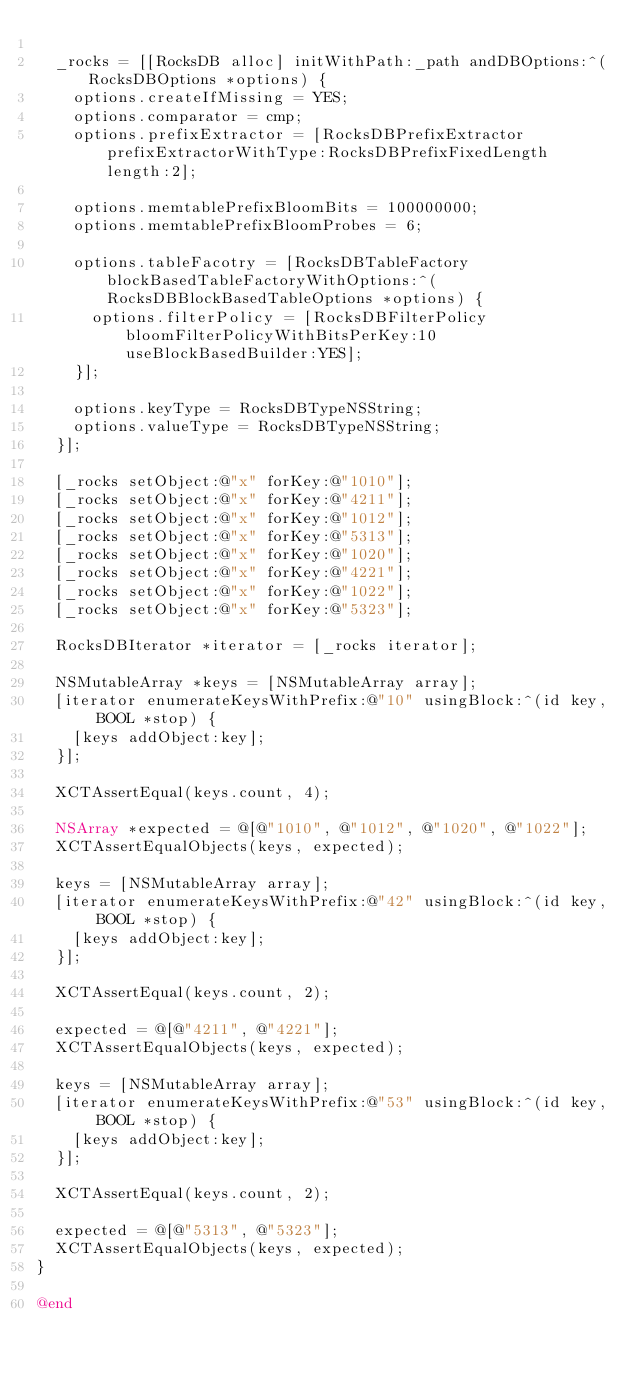<code> <loc_0><loc_0><loc_500><loc_500><_ObjectiveC_>
	_rocks = [[RocksDB alloc] initWithPath:_path andDBOptions:^(RocksDBOptions *options) {
		options.createIfMissing = YES;
		options.comparator = cmp;
		options.prefixExtractor = [RocksDBPrefixExtractor prefixExtractorWithType:RocksDBPrefixFixedLength length:2];

		options.memtablePrefixBloomBits = 100000000;
		options.memtablePrefixBloomProbes = 6;

		options.tableFacotry = [RocksDBTableFactory blockBasedTableFactoryWithOptions:^(RocksDBBlockBasedTableOptions *options) {
			options.filterPolicy = [RocksDBFilterPolicy bloomFilterPolicyWithBitsPerKey:10 useBlockBasedBuilder:YES];
		}];

		options.keyType = RocksDBTypeNSString;
		options.valueType = RocksDBTypeNSString;
	}];

	[_rocks setObject:@"x" forKey:@"1010"];
	[_rocks setObject:@"x" forKey:@"4211"];
	[_rocks setObject:@"x" forKey:@"1012"];
	[_rocks setObject:@"x" forKey:@"5313"];
	[_rocks setObject:@"x" forKey:@"1020"];
	[_rocks setObject:@"x" forKey:@"4221"];
	[_rocks setObject:@"x" forKey:@"1022"];
	[_rocks setObject:@"x" forKey:@"5323"];

	RocksDBIterator *iterator = [_rocks iterator];

	NSMutableArray *keys = [NSMutableArray array];
	[iterator enumerateKeysWithPrefix:@"10" usingBlock:^(id key, BOOL *stop) {
		[keys addObject:key];
	}];

	XCTAssertEqual(keys.count, 4);

	NSArray *expected = @[@"1010", @"1012", @"1020", @"1022"];
	XCTAssertEqualObjects(keys, expected);

	keys = [NSMutableArray array];
	[iterator enumerateKeysWithPrefix:@"42" usingBlock:^(id key, BOOL *stop) {
		[keys addObject:key];
	}];

	XCTAssertEqual(keys.count, 2);

	expected = @[@"4211", @"4221"];
	XCTAssertEqualObjects(keys, expected);

	keys = [NSMutableArray array];
	[iterator enumerateKeysWithPrefix:@"53" usingBlock:^(id key, BOOL *stop) {
		[keys addObject:key];
	}];

	XCTAssertEqual(keys.count, 2);

	expected = @[@"5313", @"5323"];
	XCTAssertEqualObjects(keys, expected);
}

@end
</code> 